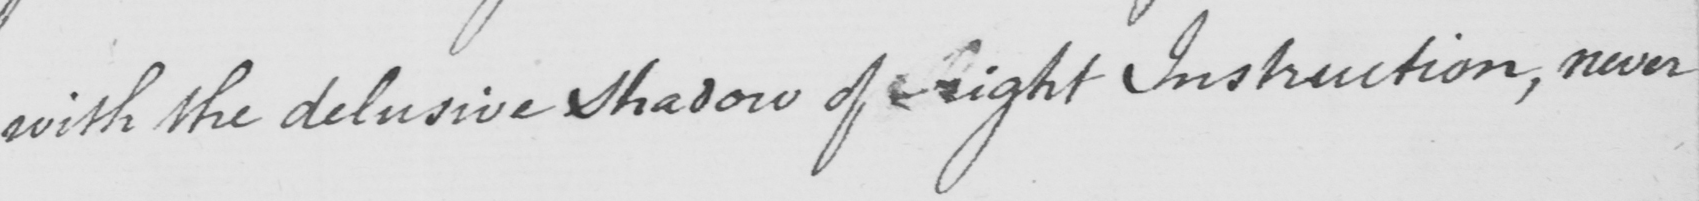Please provide the text content of this handwritten line. with the delusive shadow of Right Instruction , never 